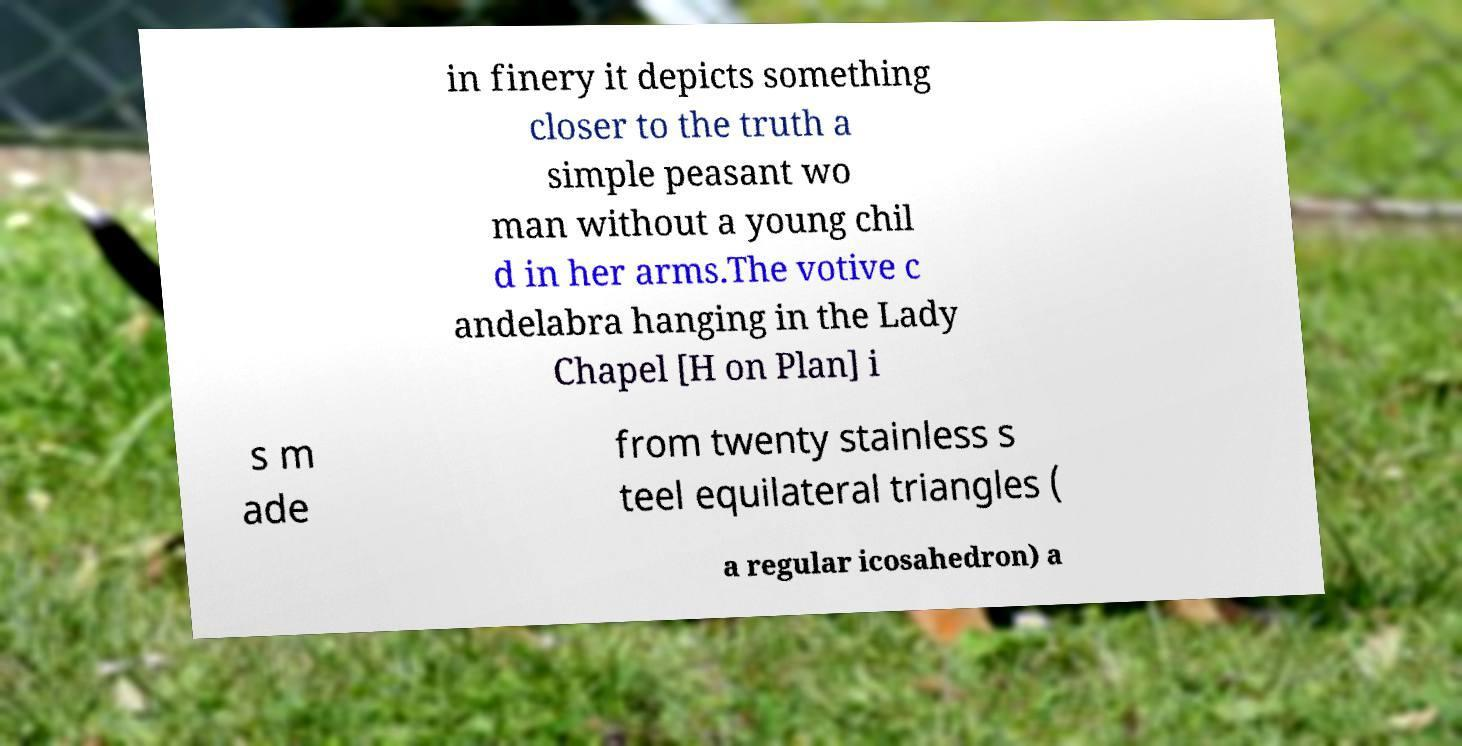Can you accurately transcribe the text from the provided image for me? in finery it depicts something closer to the truth a simple peasant wo man without a young chil d in her arms.The votive c andelabra hanging in the Lady Chapel [H on Plan] i s m ade from twenty stainless s teel equilateral triangles ( a regular icosahedron) a 